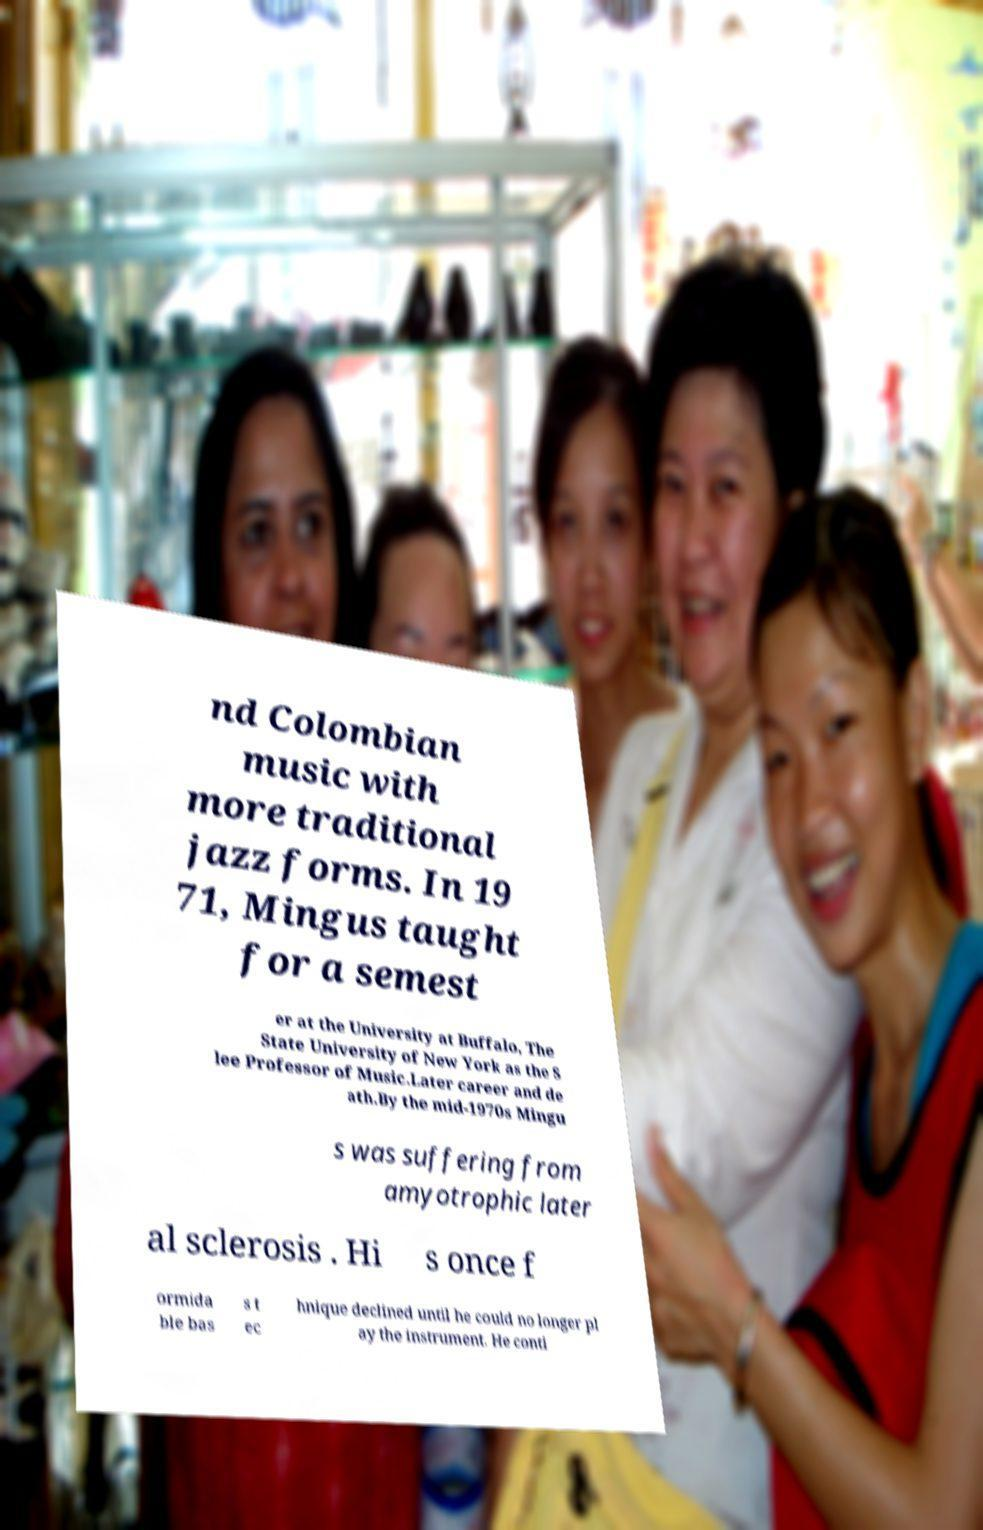Can you read and provide the text displayed in the image?This photo seems to have some interesting text. Can you extract and type it out for me? nd Colombian music with more traditional jazz forms. In 19 71, Mingus taught for a semest er at the University at Buffalo, The State University of New York as the S lee Professor of Music.Later career and de ath.By the mid-1970s Mingu s was suffering from amyotrophic later al sclerosis . Hi s once f ormida ble bas s t ec hnique declined until he could no longer pl ay the instrument. He conti 